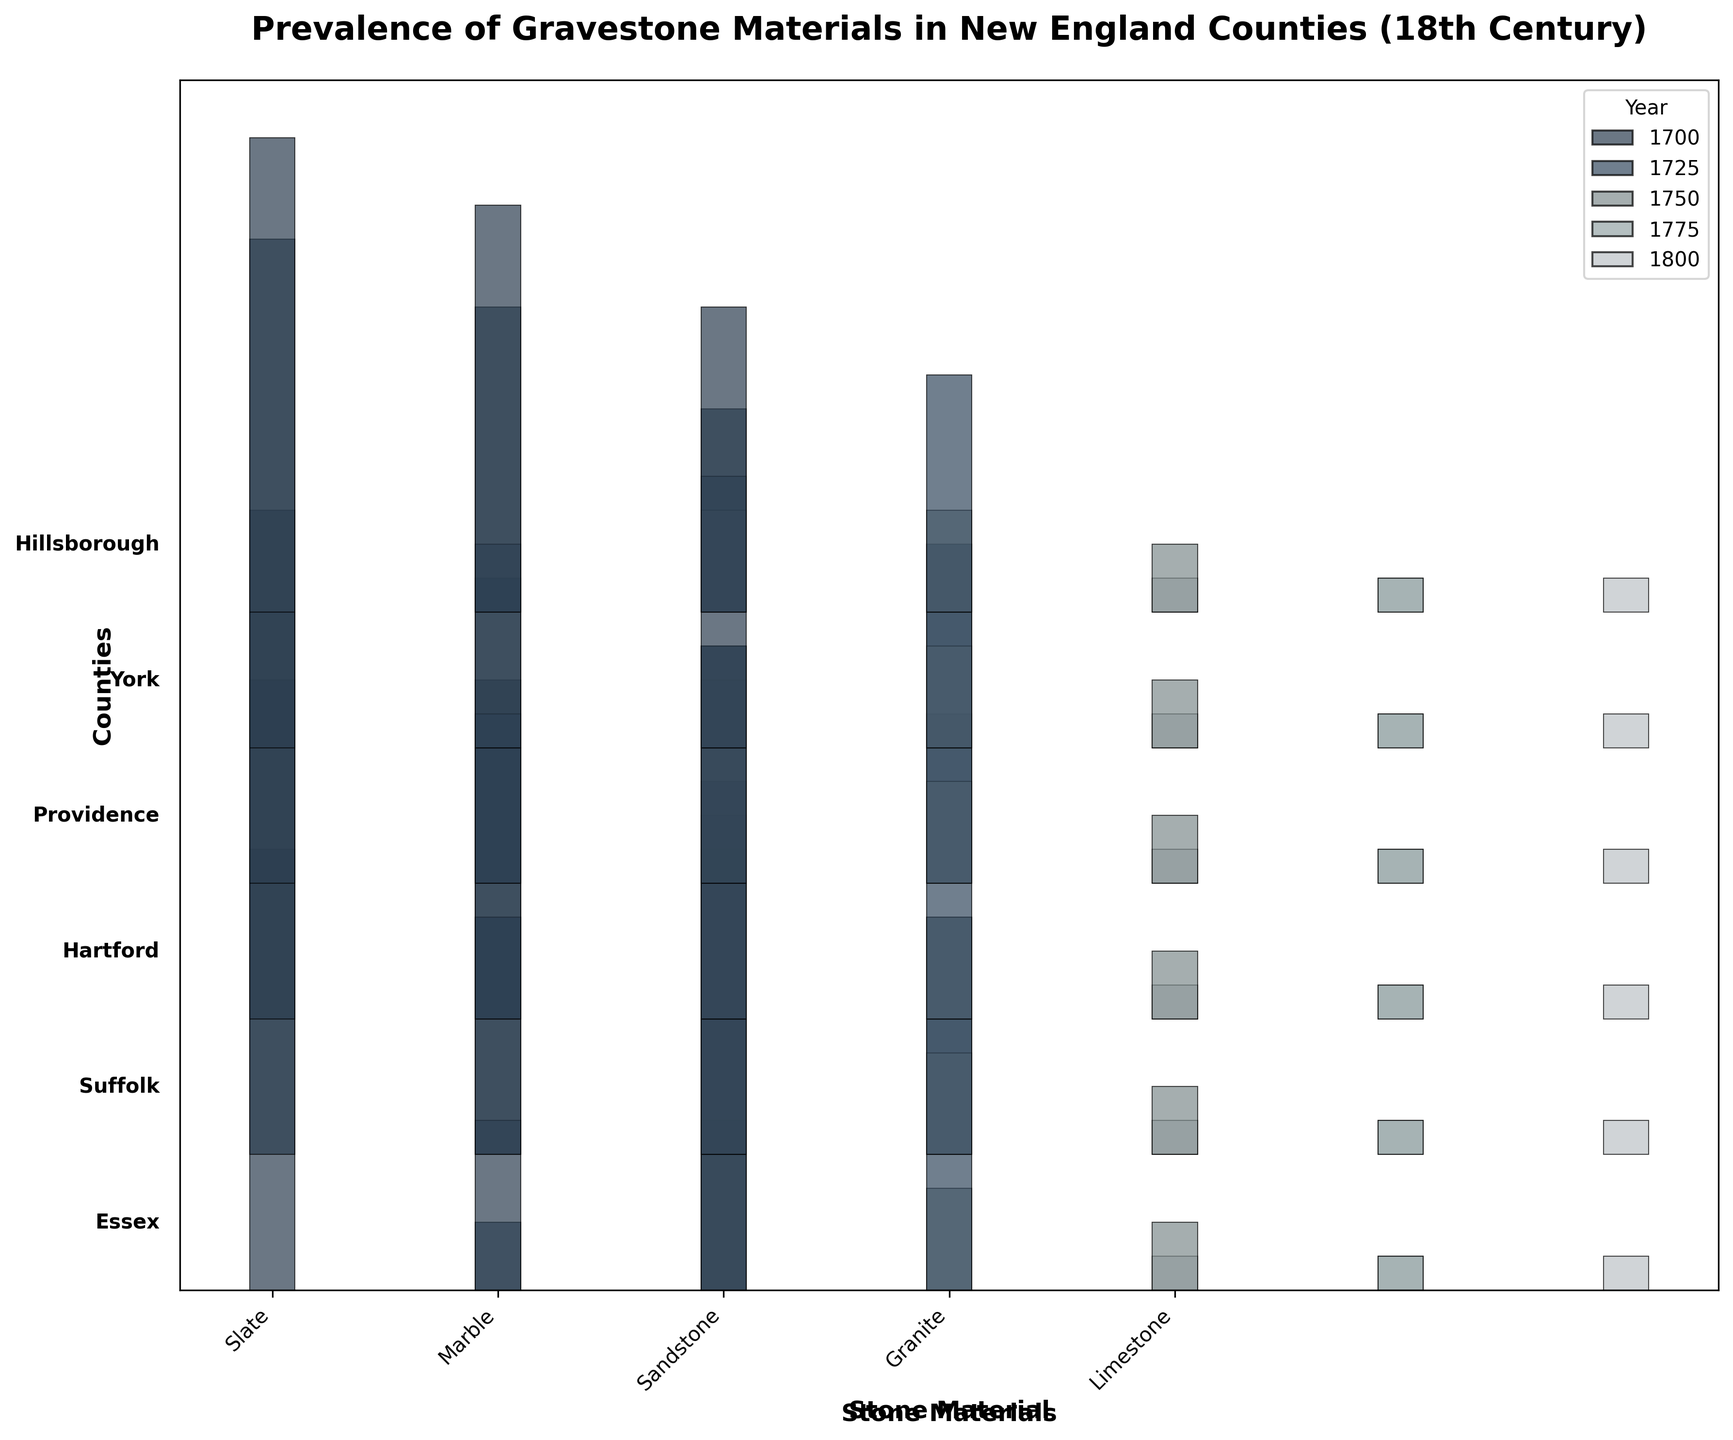Which county had granite gravestones in 1800? According to the figure, the base level for counties with granite gravestones in 1800 has some height under the Granite color. By looking closely, Essex_MA, Suffolk_MA, Hartford_CT, Providence_RI, York_ME, and Hillsborough_NH show this attribute.
Answer: Essex_MA Which stone material shows the highest consistency in use across all counties in 1700? By comparing each material's bar height across all counties in the Year 1700 row, Slate has relatively consistent high values compared to other materials.
Answer: Slate Which stone material had the largest increase in use in Providence, RI between 1700 and 1800? For Providence, RI, compare the bar heights of each stone material between 1700 and 1800. Marble shows a significant increase, going from 20 to 50.
Answer: Marble In which year did Hillsborough, NH start using marble gravestones more significantly? Looking at Hillsborough, NH at the various year intervals, marble gravestones are noticeably higher from the year 1750 compared to 1700.
Answer: 1750 Which county shows the most diverse use of gravestone materials in 1800? In 1800, compare the variety of significant bar heights across the stone materials for all counties. Providence, RI displays a more balanced variety compared to others.
Answer: Providence_RI In 1750, which county had the lowest use of sandstone gravestones? Fairfield, CT shows the smallest (or lowest) height for the sandstone bar in 1750 among all listed counties.
Answer: Fairfield_CT How does the prevalence of limestone gravestones compare between Essex, MA and Hartford, CT in 1700? Look at the height of the Limestone bars for Essex, MA and Hartford, CT in 1700. Both counties have nearly the same smaller bar heights for Limestone.
Answer: Equal What is the trend seen in the use of marble gravestones in Suffolk, MA over time? Check the Marble bar heights for each year in Suffolk, MA. Marble gravestones usage grows significantly from a small number in 1700 to a higher value in 1800.
Answer: Increasing Which county exhibits the highest use of slate as a gravestone material in 1700? Look for the tallest bar under the Slate color in all counties for the year 1700. York, ME has the highest bar for Slate in that year.
Answer: York_ME In the 18th century, which material shows a general downward trend in Essex, MA? Review the bar heights for various materials across different years in Essex, MA. Slate shows a clear downward trend from 1700 (65) to 1800 (40).
Answer: Slate 